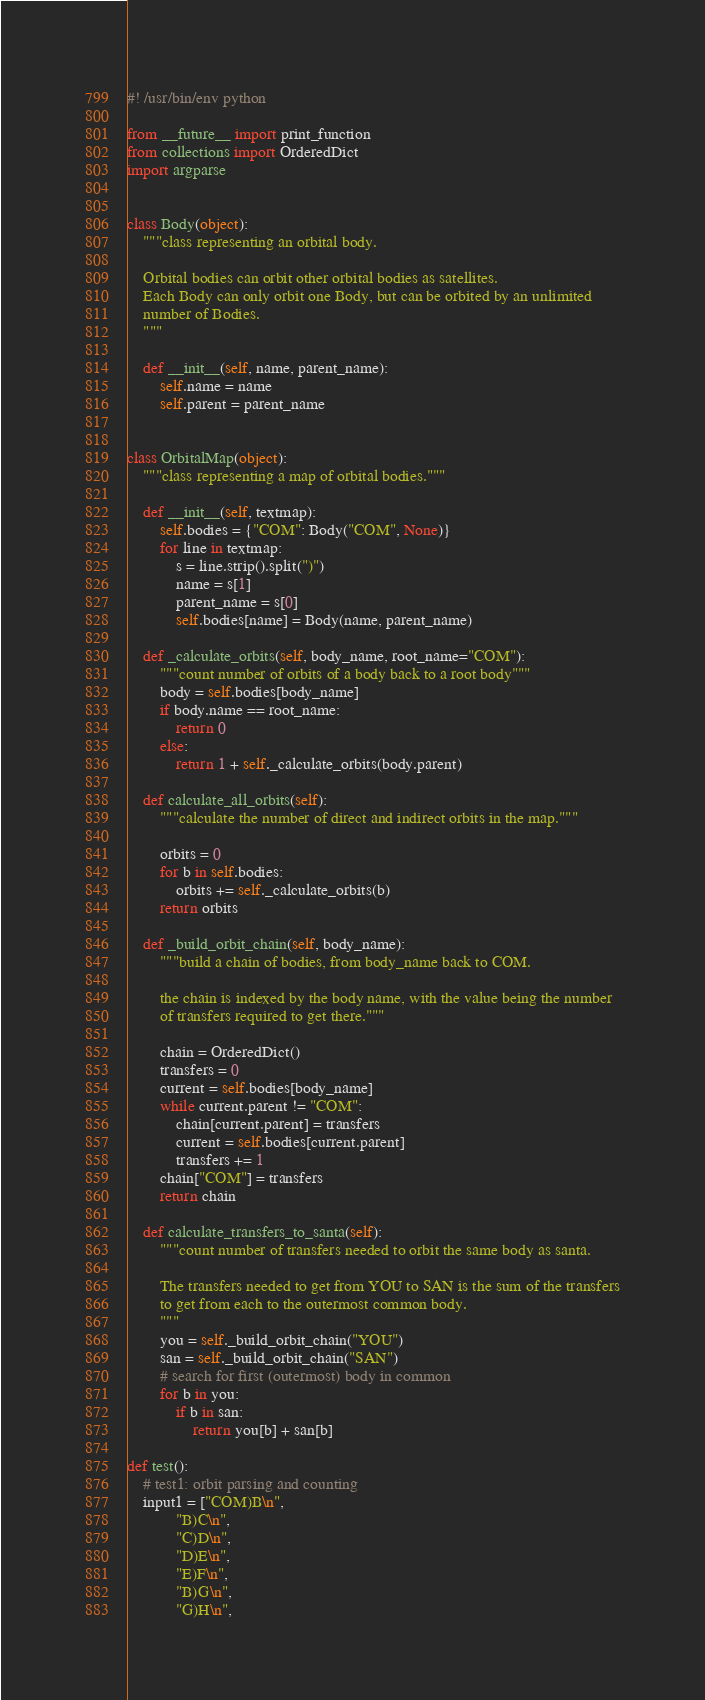<code> <loc_0><loc_0><loc_500><loc_500><_Python_>#! /usr/bin/env python

from __future__ import print_function
from collections import OrderedDict
import argparse


class Body(object):
    """class representing an orbital body.

    Orbital bodies can orbit other orbital bodies as satellites.
    Each Body can only orbit one Body, but can be orbited by an unlimited
    number of Bodies.
    """

    def __init__(self, name, parent_name):
        self.name = name
        self.parent = parent_name


class OrbitalMap(object):
    """class representing a map of orbital bodies."""

    def __init__(self, textmap):
        self.bodies = {"COM": Body("COM", None)}
        for line in textmap:
            s = line.strip().split(")")
            name = s[1]
            parent_name = s[0]
            self.bodies[name] = Body(name, parent_name)

    def _calculate_orbits(self, body_name, root_name="COM"):
        """count number of orbits of a body back to a root body"""
        body = self.bodies[body_name]
        if body.name == root_name:
            return 0
        else:
            return 1 + self._calculate_orbits(body.parent)

    def calculate_all_orbits(self):
        """calculate the number of direct and indirect orbits in the map."""

        orbits = 0
        for b in self.bodies:
            orbits += self._calculate_orbits(b)
        return orbits

    def _build_orbit_chain(self, body_name):
        """build a chain of bodies, from body_name back to COM.

        the chain is indexed by the body name, with the value being the number
        of transfers required to get there."""

        chain = OrderedDict()
        transfers = 0
        current = self.bodies[body_name]
        while current.parent != "COM":
            chain[current.parent] = transfers
            current = self.bodies[current.parent]
            transfers += 1
        chain["COM"] = transfers
        return chain

    def calculate_transfers_to_santa(self):
        """count number of transfers needed to orbit the same body as santa.

        The transfers needed to get from YOU to SAN is the sum of the transfers
        to get from each to the outermost common body.
        """
        you = self._build_orbit_chain("YOU")
        san = self._build_orbit_chain("SAN")
        # search for first (outermost) body in common
        for b in you:
            if b in san:
                return you[b] + san[b]

def test():
    # test1: orbit parsing and counting
    input1 = ["COM)B\n",
            "B)C\n",
            "C)D\n",
            "D)E\n",
            "E)F\n",
            "B)G\n",
            "G)H\n",</code> 